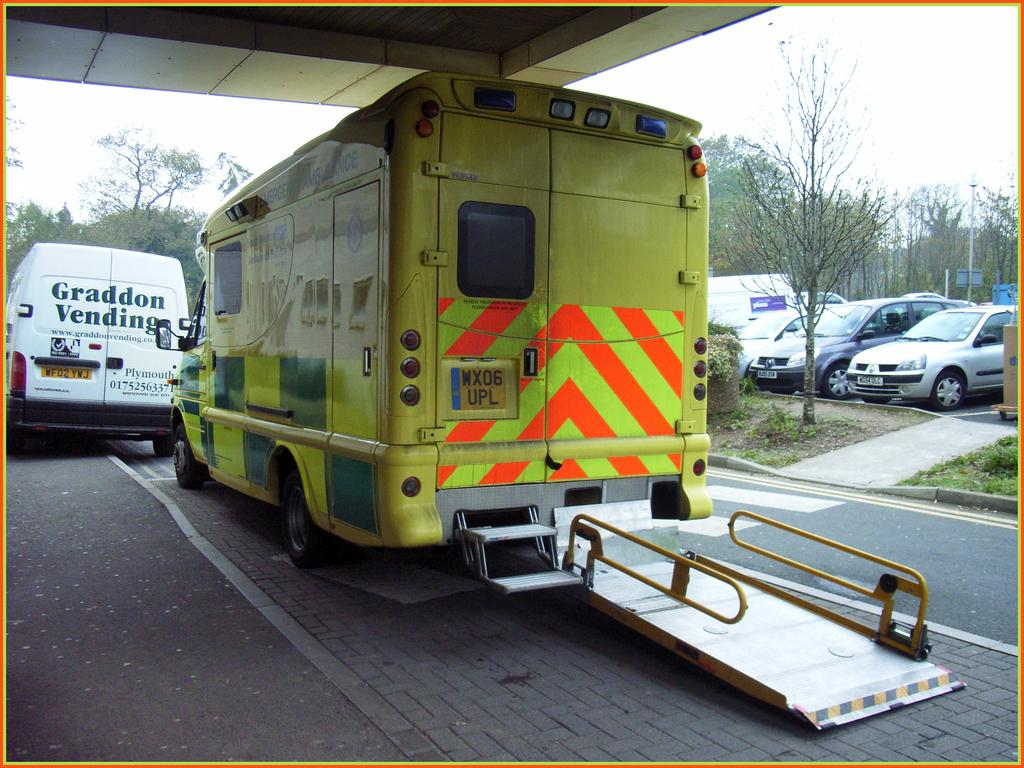What types of objects are present in the image? There are vehicles in the image. What can be seen in the middle of the image? There are trees in the middle of the image. What is visible at the top of the image? There is a ceiling and the sky visible at the top of the image. What type of ray is swimming in the image? There is no ray present in the image; it features vehicles, trees, a ceiling, and the sky. How is the unit being used in the image? There is no unit present in the image, so it cannot be used or observed. 